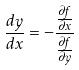<formula> <loc_0><loc_0><loc_500><loc_500>\frac { d y } { d x } = - \frac { \frac { \partial f } { \partial x } } { \frac { \partial f } { \partial y } }</formula> 